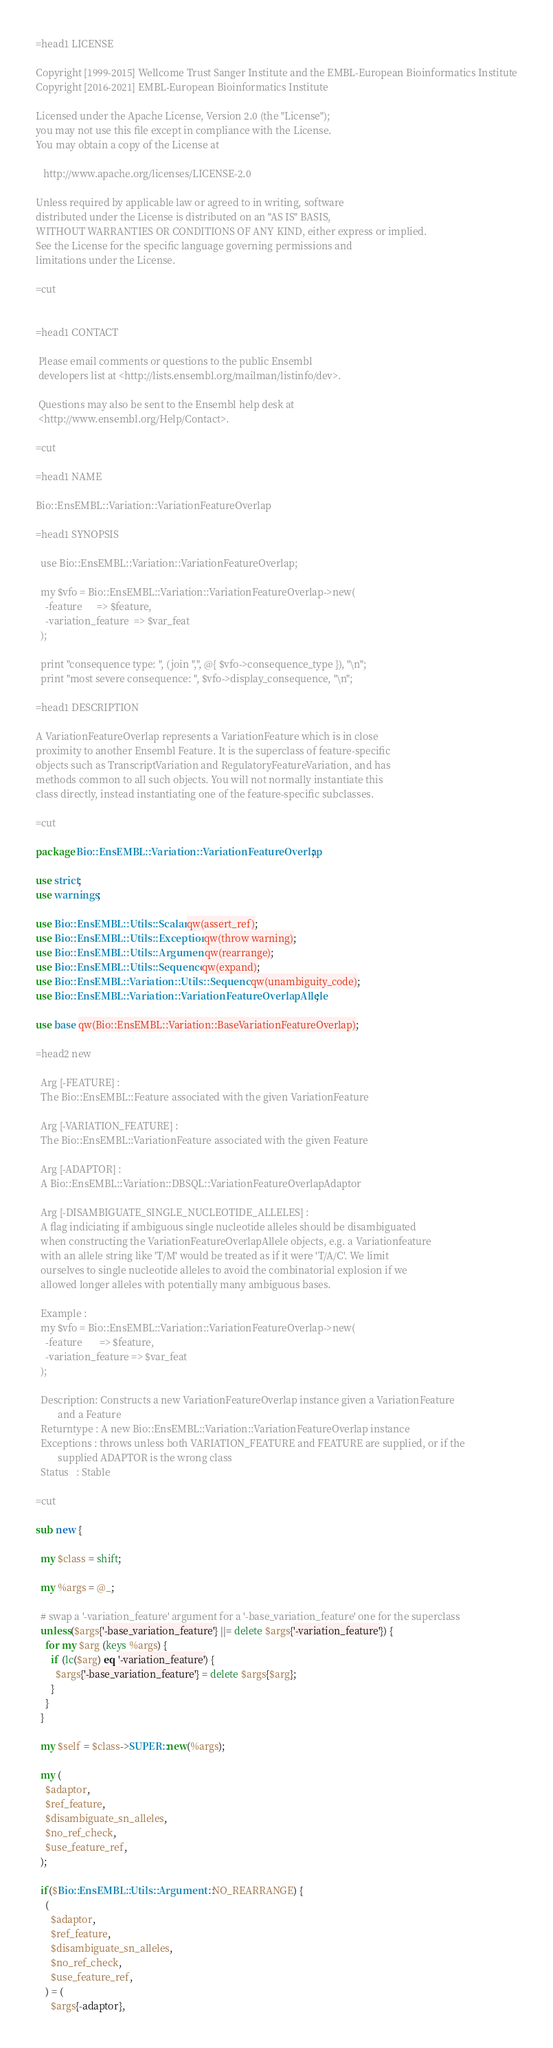Convert code to text. <code><loc_0><loc_0><loc_500><loc_500><_Perl_>=head1 LICENSE

Copyright [1999-2015] Wellcome Trust Sanger Institute and the EMBL-European Bioinformatics Institute
Copyright [2016-2021] EMBL-European Bioinformatics Institute

Licensed under the Apache License, Version 2.0 (the "License");
you may not use this file except in compliance with the License.
You may obtain a copy of the License at

   http://www.apache.org/licenses/LICENSE-2.0

Unless required by applicable law or agreed to in writing, software
distributed under the License is distributed on an "AS IS" BASIS,
WITHOUT WARRANTIES OR CONDITIONS OF ANY KIND, either express or implied.
See the License for the specific language governing permissions and
limitations under the License.

=cut


=head1 CONTACT

 Please email comments or questions to the public Ensembl
 developers list at <http://lists.ensembl.org/mailman/listinfo/dev>.

 Questions may also be sent to the Ensembl help desk at
 <http://www.ensembl.org/Help/Contact>.

=cut

=head1 NAME

Bio::EnsEMBL::Variation::VariationFeatureOverlap

=head1 SYNOPSIS

  use Bio::EnsEMBL::Variation::VariationFeatureOverlap;

  my $vfo = Bio::EnsEMBL::Variation::VariationFeatureOverlap->new(
    -feature      => $feature,
    -variation_feature  => $var_feat
  );

  print "consequence type: ", (join ",", @{ $vfo->consequence_type }), "\n";
  print "most severe consequence: ", $vfo->display_consequence, "\n";

=head1 DESCRIPTION

A VariationFeatureOverlap represents a VariationFeature which is in close
proximity to another Ensembl Feature. It is the superclass of feature-specific
objects such as TranscriptVariation and RegulatoryFeatureVariation, and has
methods common to all such objects. You will not normally instantiate this
class directly, instead instantiating one of the feature-specific subclasses.

=cut

package Bio::EnsEMBL::Variation::VariationFeatureOverlap;

use strict;
use warnings;

use Bio::EnsEMBL::Utils::Scalar qw(assert_ref);
use Bio::EnsEMBL::Utils::Exception qw(throw warning);
use Bio::EnsEMBL::Utils::Argument qw(rearrange);
use Bio::EnsEMBL::Utils::Sequence qw(expand);
use Bio::EnsEMBL::Variation::Utils::Sequence qw(unambiguity_code);
use Bio::EnsEMBL::Variation::VariationFeatureOverlapAllele;

use base qw(Bio::EnsEMBL::Variation::BaseVariationFeatureOverlap);

=head2 new

  Arg [-FEATURE] : 
  The Bio::EnsEMBL::Feature associated with the given VariationFeature

  Arg [-VARIATION_FEATURE] :
  The Bio::EnsEMBL::VariationFeature associated with the given Feature

  Arg [-ADAPTOR] :
  A Bio::EnsEMBL::Variation::DBSQL::VariationFeatureOverlapAdaptor

  Arg [-DISAMBIGUATE_SINGLE_NUCLEOTIDE_ALLELES] :
  A flag indiciating if ambiguous single nucleotide alleles should be disambiguated
  when constructing the VariationFeatureOverlapAllele objects, e.g. a Variationfeature
  with an allele string like 'T/M' would be treated as if it were 'T/A/C'. We limit
  ourselves to single nucleotide alleles to avoid the combinatorial explosion if we
  allowed longer alleles with potentially many ambiguous bases.

  Example : 
  my $vfo = Bio::EnsEMBL::Variation::VariationFeatureOverlap->new(
    -feature       => $feature,
    -variation_feature => $var_feat
  );

  Description: Constructs a new VariationFeatureOverlap instance given a VariationFeature
         and a Feature
  Returntype : A new Bio::EnsEMBL::Variation::VariationFeatureOverlap instance 
  Exceptions : throws unless both VARIATION_FEATURE and FEATURE are supplied, or if the
         supplied ADAPTOR is the wrong class
  Status   : Stable

=cut 

sub new {

  my $class = shift;
   
  my %args = @_;

  # swap a '-variation_feature' argument for a '-base_variation_feature' one for the superclass
  unless($args{'-base_variation_feature'} ||= delete $args{'-variation_feature'}) {
    for my $arg (keys %args) {
      if (lc($arg) eq '-variation_feature') {
        $args{'-base_variation_feature'} = delete $args{$arg};
      }
    }
  }

  my $self = $class->SUPER::new(%args);

  my (
    $adaptor, 
    $ref_feature, 
    $disambiguate_sn_alleles,
    $no_ref_check,
    $use_feature_ref,
  );

  if($Bio::EnsEMBL::Utils::Argument::NO_REARRANGE) {
    (
      $adaptor, 
      $ref_feature, 
      $disambiguate_sn_alleles,
      $no_ref_check,
      $use_feature_ref,
    ) = (
      $args{-adaptor},</code> 